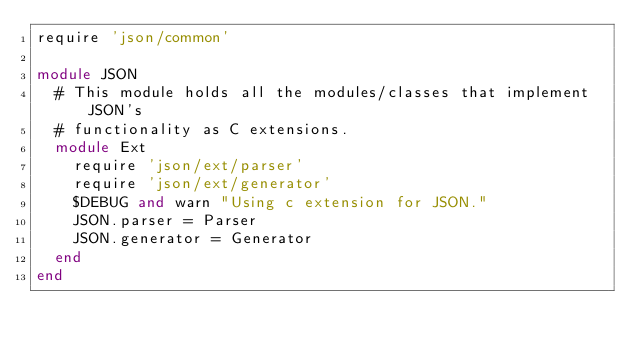Convert code to text. <code><loc_0><loc_0><loc_500><loc_500><_Ruby_>require 'json/common'

module JSON
  # This module holds all the modules/classes that implement JSON's
  # functionality as C extensions.
  module Ext
    require 'json/ext/parser'
    require 'json/ext/generator'
    $DEBUG and warn "Using c extension for JSON."
    JSON.parser = Parser
    JSON.generator = Generator
  end
end
</code> 